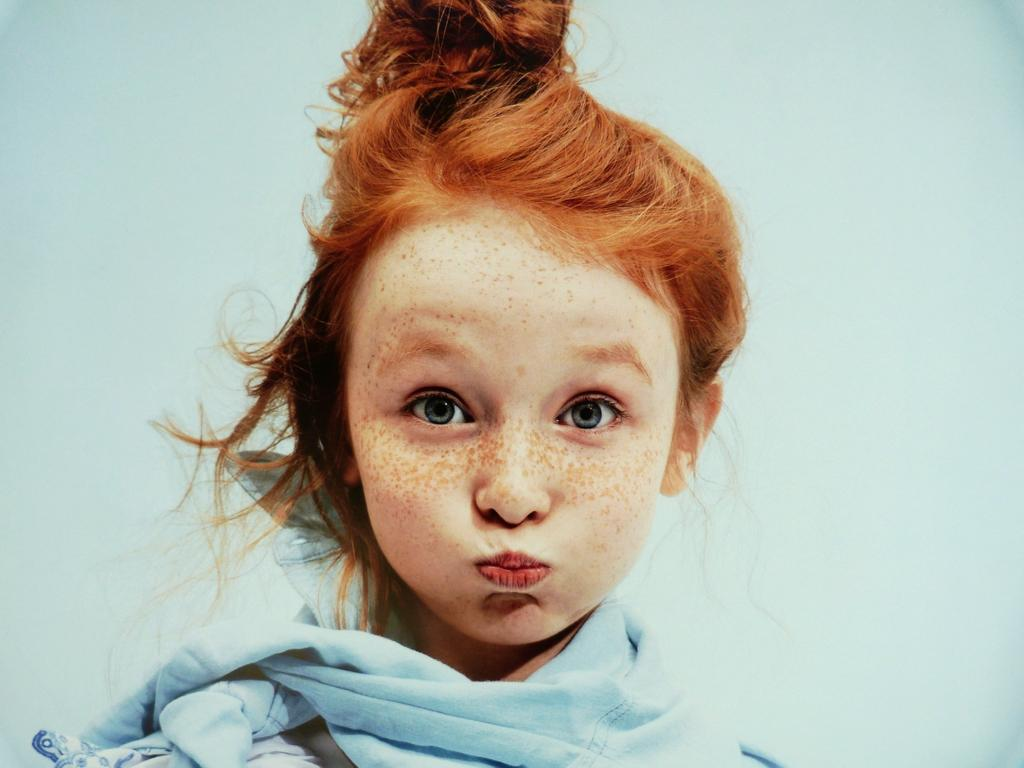Who is the main subject in the image? There is a girl in the image. Can you describe the girl's hair color? The girl has golden hair. What is the girl wearing in the image? The girl is wearing a blue scarf. Where is the girl standing in the image? The girl is standing in front of a wall. How long does it take for the girl to create a piece of art in the image? There is no indication in the image that the girl is creating a piece of art, so it cannot be determined from the picture. 